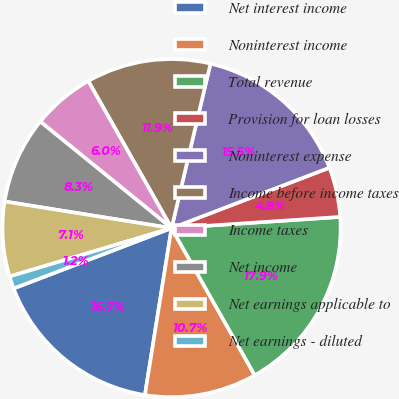Convert chart to OTSL. <chart><loc_0><loc_0><loc_500><loc_500><pie_chart><fcel>Net interest income<fcel>Noninterest income<fcel>Total revenue<fcel>Provision for loan losses<fcel>Noninterest expense<fcel>Income before income taxes<fcel>Income taxes<fcel>Net income<fcel>Net earnings applicable to<fcel>Net earnings - diluted<nl><fcel>16.67%<fcel>10.71%<fcel>17.86%<fcel>4.76%<fcel>15.48%<fcel>11.9%<fcel>5.95%<fcel>8.33%<fcel>7.14%<fcel>1.19%<nl></chart> 